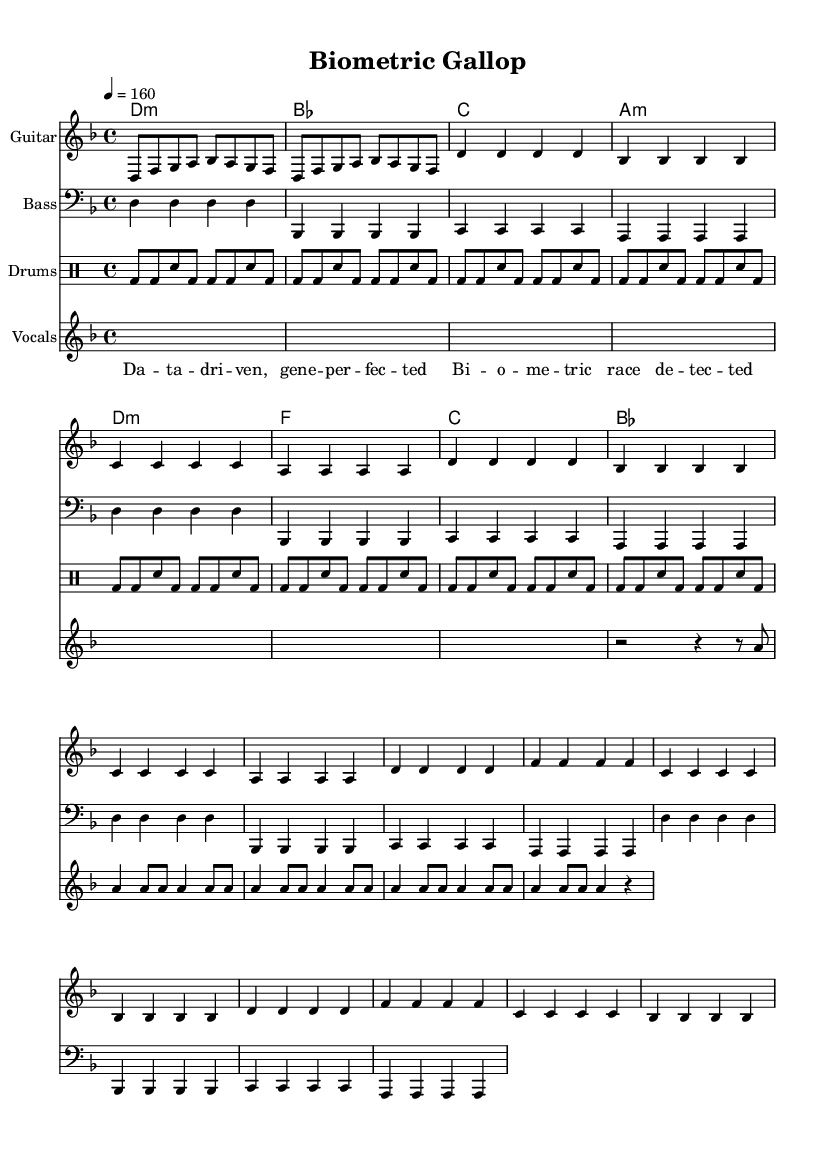What is the key signature of this music? The key signature is D minor, which has one flat (B flat) indicated in the sheet music.
Answer: D minor What is the time signature of this piece? The time signature is 4/4, which is shown after the key signature in the music. This means there are four beats in each measure.
Answer: 4/4 What is the tempo of the piece? The tempo is indicated as 160 beats per minute, showing how fast the music should be played. It's located at the beginning of the score.
Answer: 160 How many measures are in the guitar music? The guitar music section comprises four main measures, repeated in the indicated sections contributing to a total of eight measures. Each repeat counts as an additional measure.
Answer: 8 What is the specific vocal lyric pattern used in the lyrics? The lyrics follow a rhythmic structure featuring a repetitive pattern, specifically with a heavy emphasis on syllable counts per line, showcasing the upbeat and aggressive nature typical of metal music.
Answer: Da – ta – dri – ven What type of musical instruments are included in the composition? The composition includes the guitar, bass, drums, and vocals, as shown in the different staffs within the score. Each instrument is represented by a different staff or section.
Answer: Guitar, Bass, Drums, Vocals Is the piece primarily written for solo instruments or a full band? The piece is written for a full band setup, as indicated by the presence of multiple staves for different instruments, coupled with vocal lyrics making it a complete ensemble experience.
Answer: Full band 